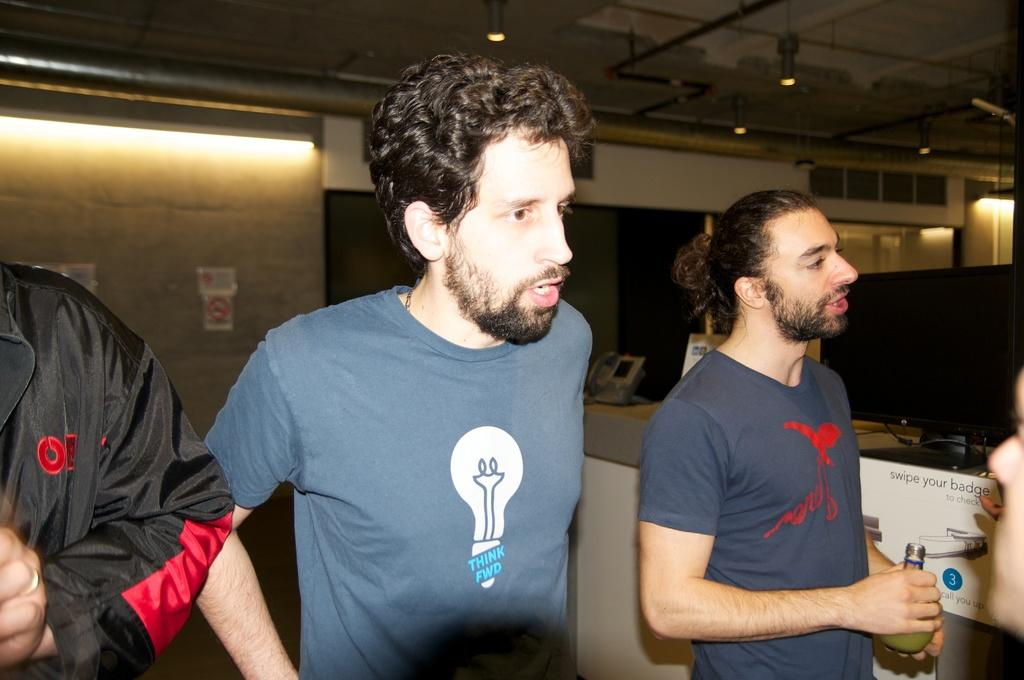Provide a one-sentence caption for the provided image. Three people are standing next to a sign that says swipe your badge to check. 